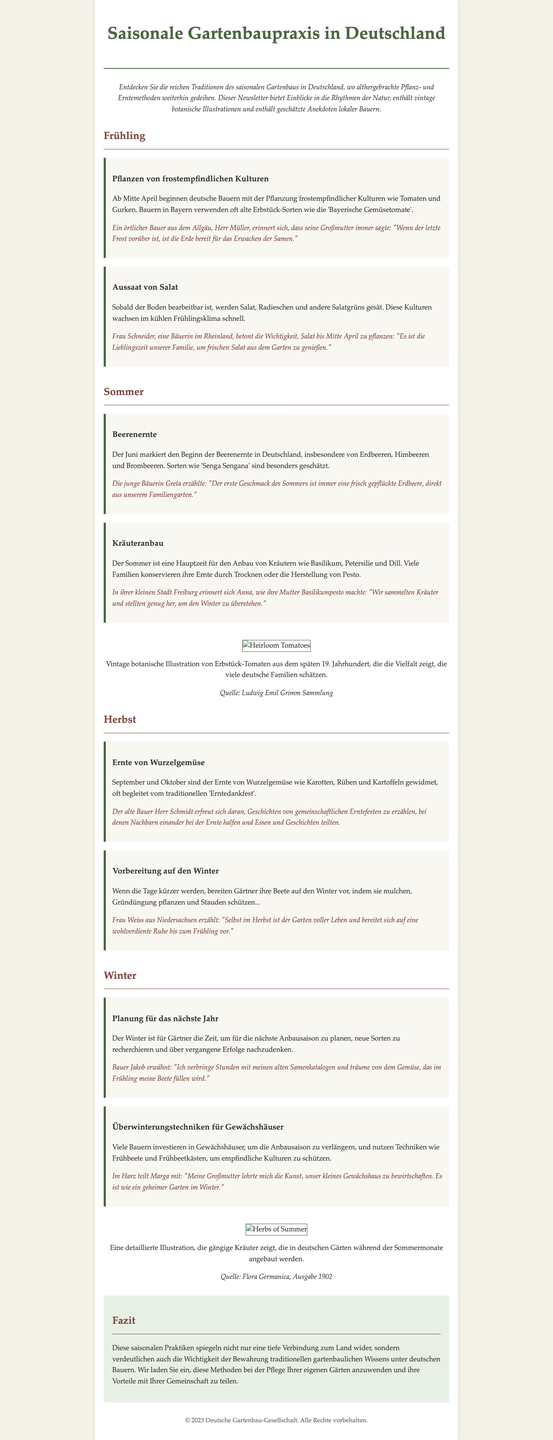What is the main theme of the newsletter? The main theme of the newsletter is the traditional seasonal planting and harvesting methods that have persisted through generations in Germany.
Answer: traditionelle saisonale Pflanz- und Erntemethoden When do German farmers start planting frost-sensitive crops? According to the document, German farmers start planting frost-sensitive crops like tomatoes and cucumbers from mid-April.
Answer: Mitte April What is the vintage botanical illustration featured for tomatoes from? The vintage botanical illustration of heirloom tomatoes is from the late 19th century.
Answer: späten 19. Jahrhundert Which berry marks the beginning of the harvest season in June? The document states that strawberries begin the harvest season in June.
Answer: Erdbeeren Who emphasizes the importance of planting salad by mid-April? Frau Schneider, a farmer in the Rheinland, emphasizes the importance of planting salad by mid-April.
Answer: Frau Schneider What activity do gardeners focus on during winter? During winter, gardeners focus on planning for the next growing season.
Answer: Planung für das nächste Jahr What is the traditional celebration associated with the harvest of root vegetables? The traditional celebration associated with the harvest of root vegetables is called 'Erntedankfest.'
Answer: Erntedankfest What type of techniques do many farmers use to extend the growing season? Many farmers use greenhouse techniques to extend the growing season.
Answer: Gewächshaus What kind of crops do farmers in summer predominantly grow? Farmers predominantly grow herbs like basil, parsley, and dill in the summer.
Answer: Kräuter 